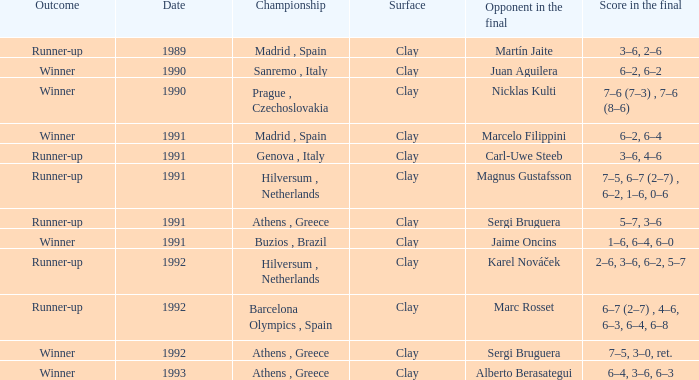What is Score In The Final, when Championship is "Athens , Greece", and when Outcome is "Winner"? 7–5, 3–0, ret., 6–4, 3–6, 6–3. 